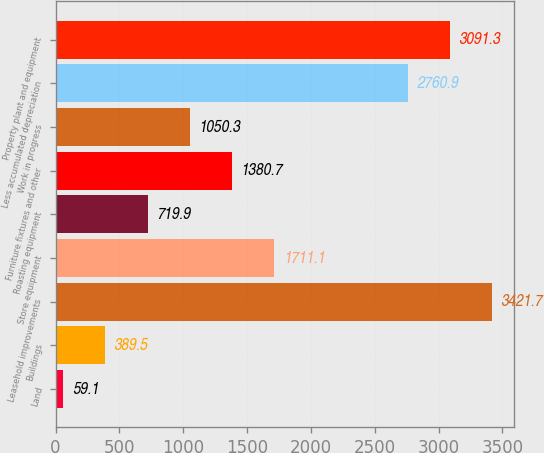Convert chart. <chart><loc_0><loc_0><loc_500><loc_500><bar_chart><fcel>Land<fcel>Buildings<fcel>Leasehold improvements<fcel>Store equipment<fcel>Roasting equipment<fcel>Furniture fixtures and other<fcel>Work in progress<fcel>Less accumulated depreciation<fcel>Property plant and equipment<nl><fcel>59.1<fcel>389.5<fcel>3421.7<fcel>1711.1<fcel>719.9<fcel>1380.7<fcel>1050.3<fcel>2760.9<fcel>3091.3<nl></chart> 